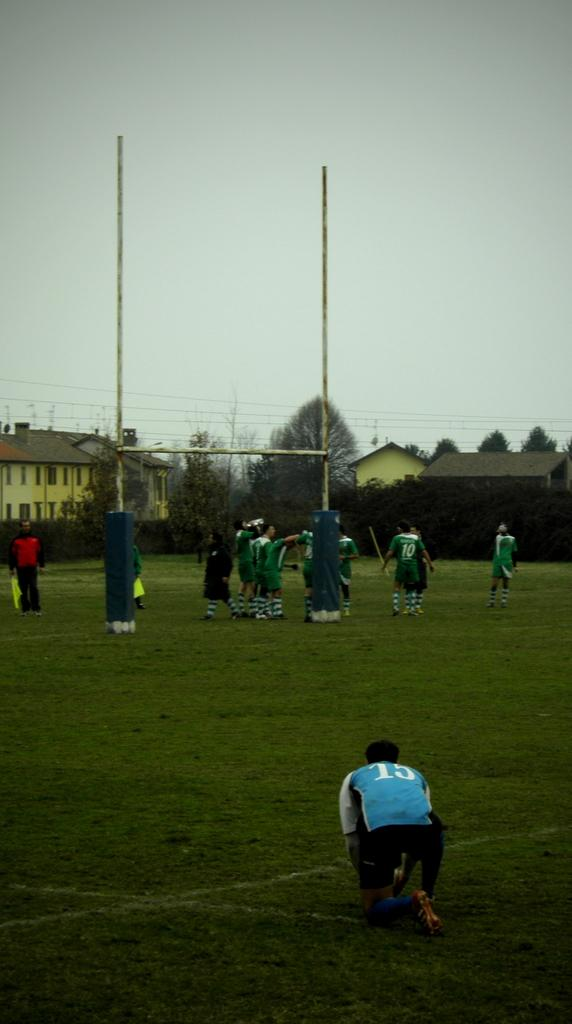What is the person on the grass floor doing? The facts do not specify what the person is doing on the grass floor. How many people are visible in the image? There are other people in the image, but the exact number is not specified. What is the purpose of the net in the image? The purpose of the net is not specified in the facts. What type of structures can be seen in the image? There are houses in the image. What else can be seen in the image besides the people and houses? There are wires and trees in the image. What type of pollution can be seen in the image? There is no mention of pollution in the image. How many trains are visible in the image? There is no mention of trains in the image. What shape is the person on the grass floor? The facts do not specify the shape of the person on the grass floor. 